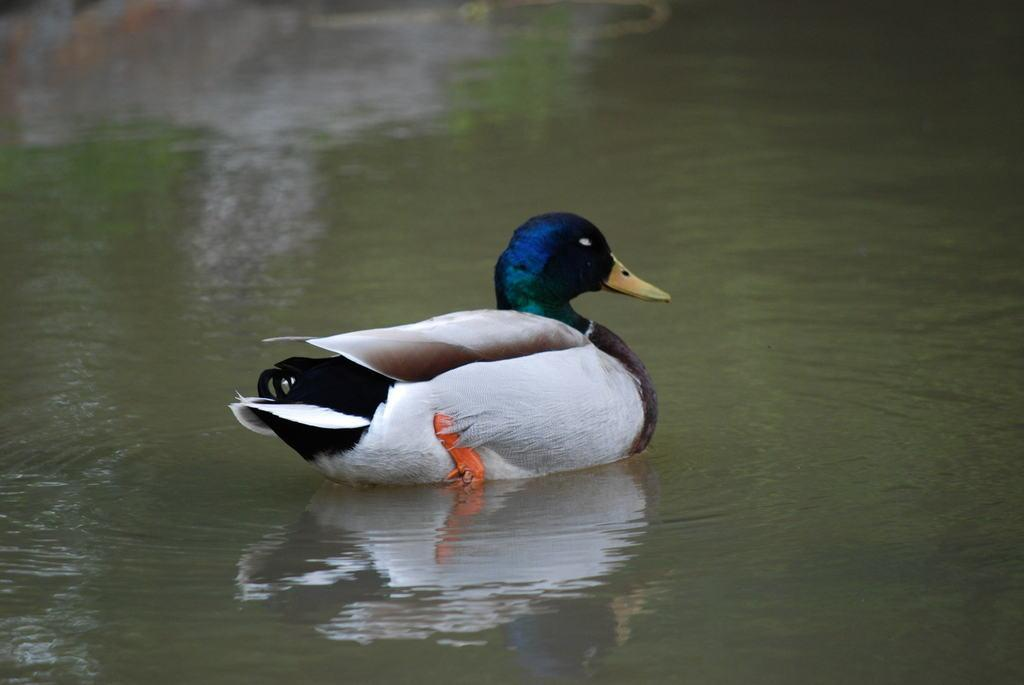What is the main subject of the image? There is a duck in the center of the image. Where is the duck located? The duck is in the water. What type of footwear is the lawyer wearing while smoking a pipe in the image? There is no lawyer, footwear, or pipe present in the image; it features a duck in the water. 